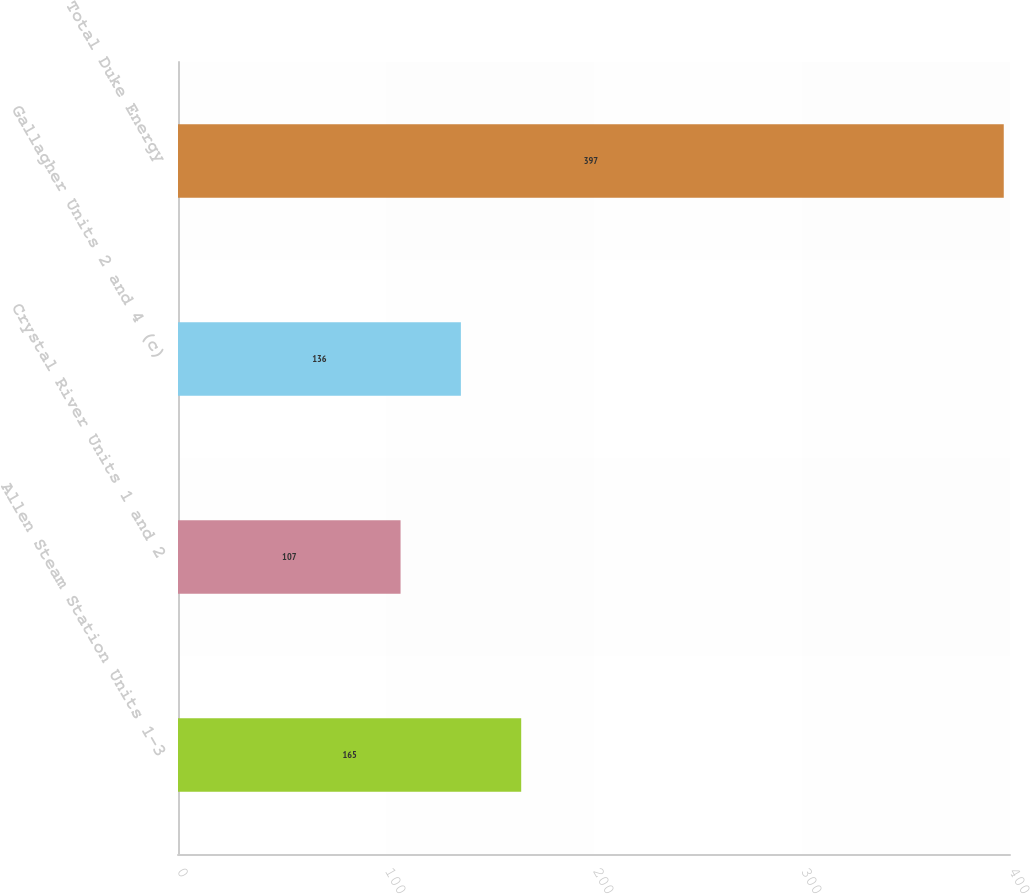Convert chart to OTSL. <chart><loc_0><loc_0><loc_500><loc_500><bar_chart><fcel>Allen Steam Station Units 1-3<fcel>Crystal River Units 1 and 2<fcel>Gallagher Units 2 and 4 (c)<fcel>Total Duke Energy<nl><fcel>165<fcel>107<fcel>136<fcel>397<nl></chart> 